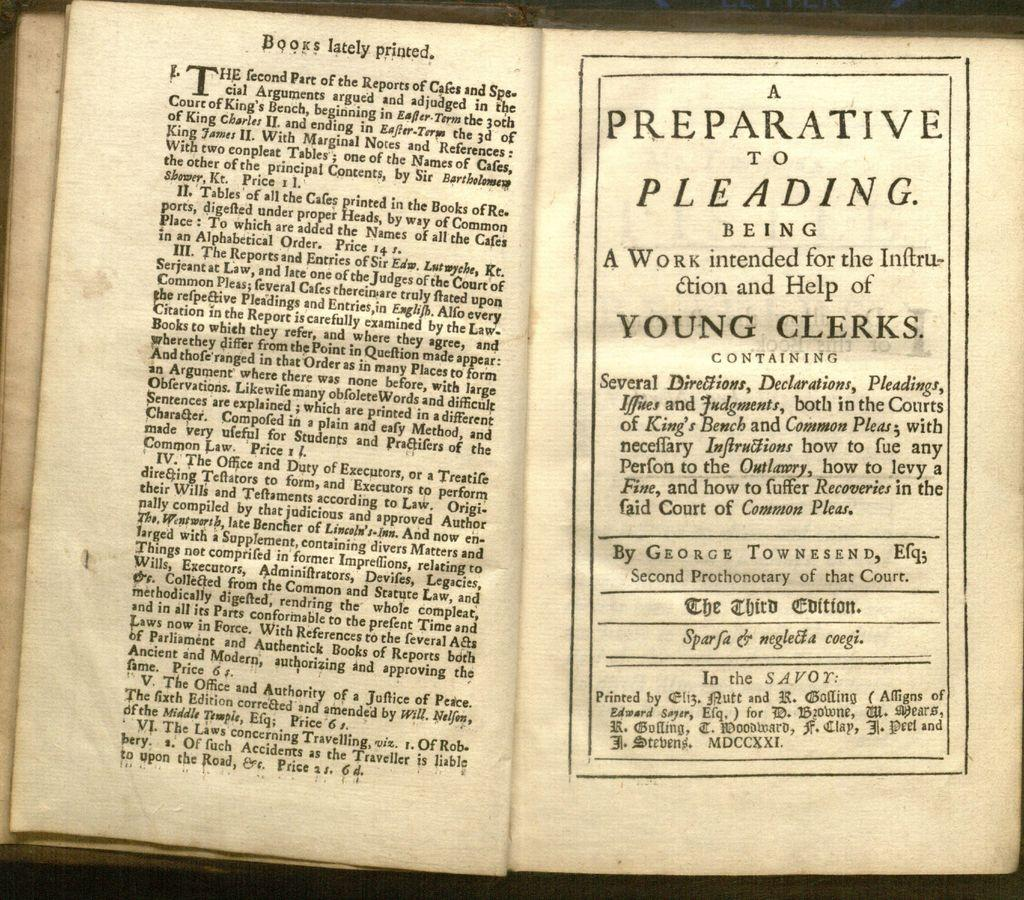<image>
Provide a brief description of the given image. a few open pages of an old book entitled A PREPARATIVE TO PLEADING By GEORGE TOWNSEND. 